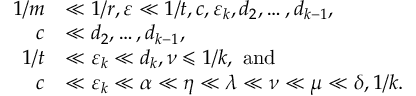<formula> <loc_0><loc_0><loc_500><loc_500>\begin{array} { r l } { 1 / m } & { \ll 1 / r , \varepsilon \ll 1 / t , c , \varepsilon _ { k } , d _ { 2 } , \dots , d _ { k - 1 } , } \\ { c } & { \ll d _ { 2 } , \dots , d _ { k - 1 } , } \\ { 1 / t } & { \ll \varepsilon _ { k } \ll d _ { k } , \nu \leqslant 1 / k , a n d } \\ { c } & { \ll \varepsilon _ { k } \ll \alpha \ll \eta \ll \lambda \ll \nu \ll \mu \ll \delta , 1 / k . } \end{array}</formula> 